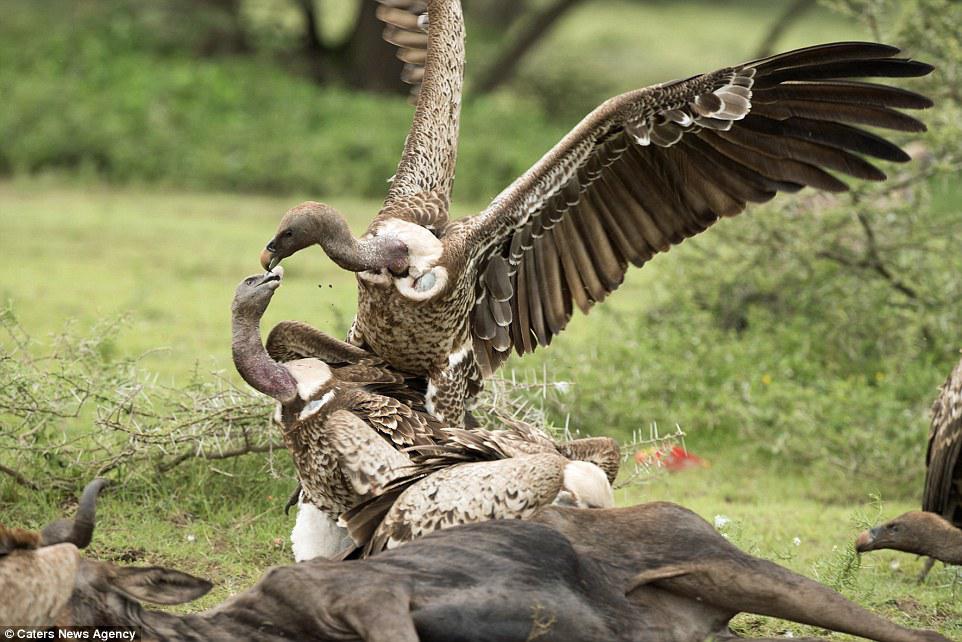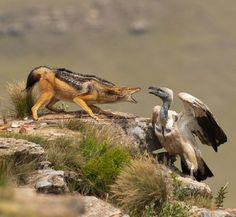The first image is the image on the left, the second image is the image on the right. Considering the images on both sides, is "A vulture is face-to-face with a jackal standing in profile on all fours, in one image." valid? Answer yes or no. Yes. 